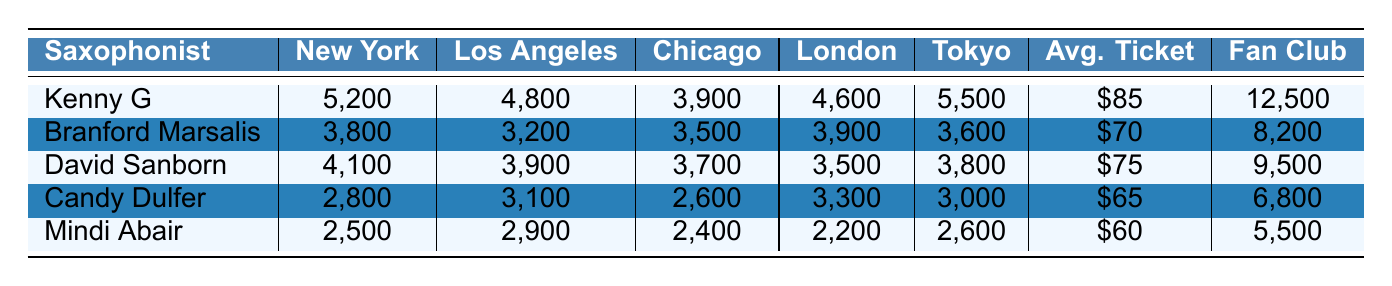What saxophonist had the highest attendance in Tokyo? From the attendance data for Tokyo, Kenny G had 5,500 attendees, which is higher than any other saxophonist's attendance in that city.
Answer: Kenny G Which saxophonist had the lowest average ticket price? Looking at the average ticket prices, Mindi Abair has the lowest price at $60, which is less than the prices of all other saxophonists.
Answer: Mindi Abair What is the total attendance for Candy Dulfer across all cities? The attendance for Candy Dulfer in each city is as follows: New York (2,800) + Los Angeles (3,100) + Chicago (2,600) + London (3,300) + Tokyo (3,000). Adding these amounts gives a total of 14,900.
Answer: 14,900 Which saxophonist has the most fan club members? By comparing the fan club membership numbers, Kenny G has 12,500 members, which is the highest among all saxophonists.
Answer: Kenny G What is the difference in attendance between the highest and lowest attended concert for Mindi Abair? Mindi Abair’s highest attendance is in Los Angeles (2,900) and lowest in London (2,200). The difference is 2,900 - 2,200 = 700.
Answer: 700 Which city had the highest attendance for David Sanborn? From the attendance values for David Sanborn, New York shows 4,100, which is more than in Los Angeles (3,900), Chicago (3,700), London (3,500), and Tokyo (3,800).
Answer: New York How much higher is Kenny G's attendance in New York compared to Mindi Abair's attendance? Kenny G's attendance in New York is 5,200, while Mindi Abair's is 2,500. The difference is 5,200 - 2,500 = 2,700.
Answer: 2,700 Which saxophonist has the lowest concert attendance in Chicago? The attendance data for Chicago shows that Mindi Abair has the lowest attendance at 2,400, lower than all other saxophonists.
Answer: Mindi Abair What is the average attendance of Branford Marsalis across all cities? To calculate the average for Branford Marsalis, sum his attendance values: 3,800 + 3,200 + 3,500 + 3,900 + 3,600 = 18,000. Dividing by the number of cities (5) gives an average of 18,000 / 5 = 3,600.
Answer: 3,600 Is the average ticket price for Kenny G more than that of Candy Dulfer? Kenny G’s average ticket price is $85, while Candy Dulfer's is $65. Since $85 is greater than $65, the answer is yes.
Answer: Yes 